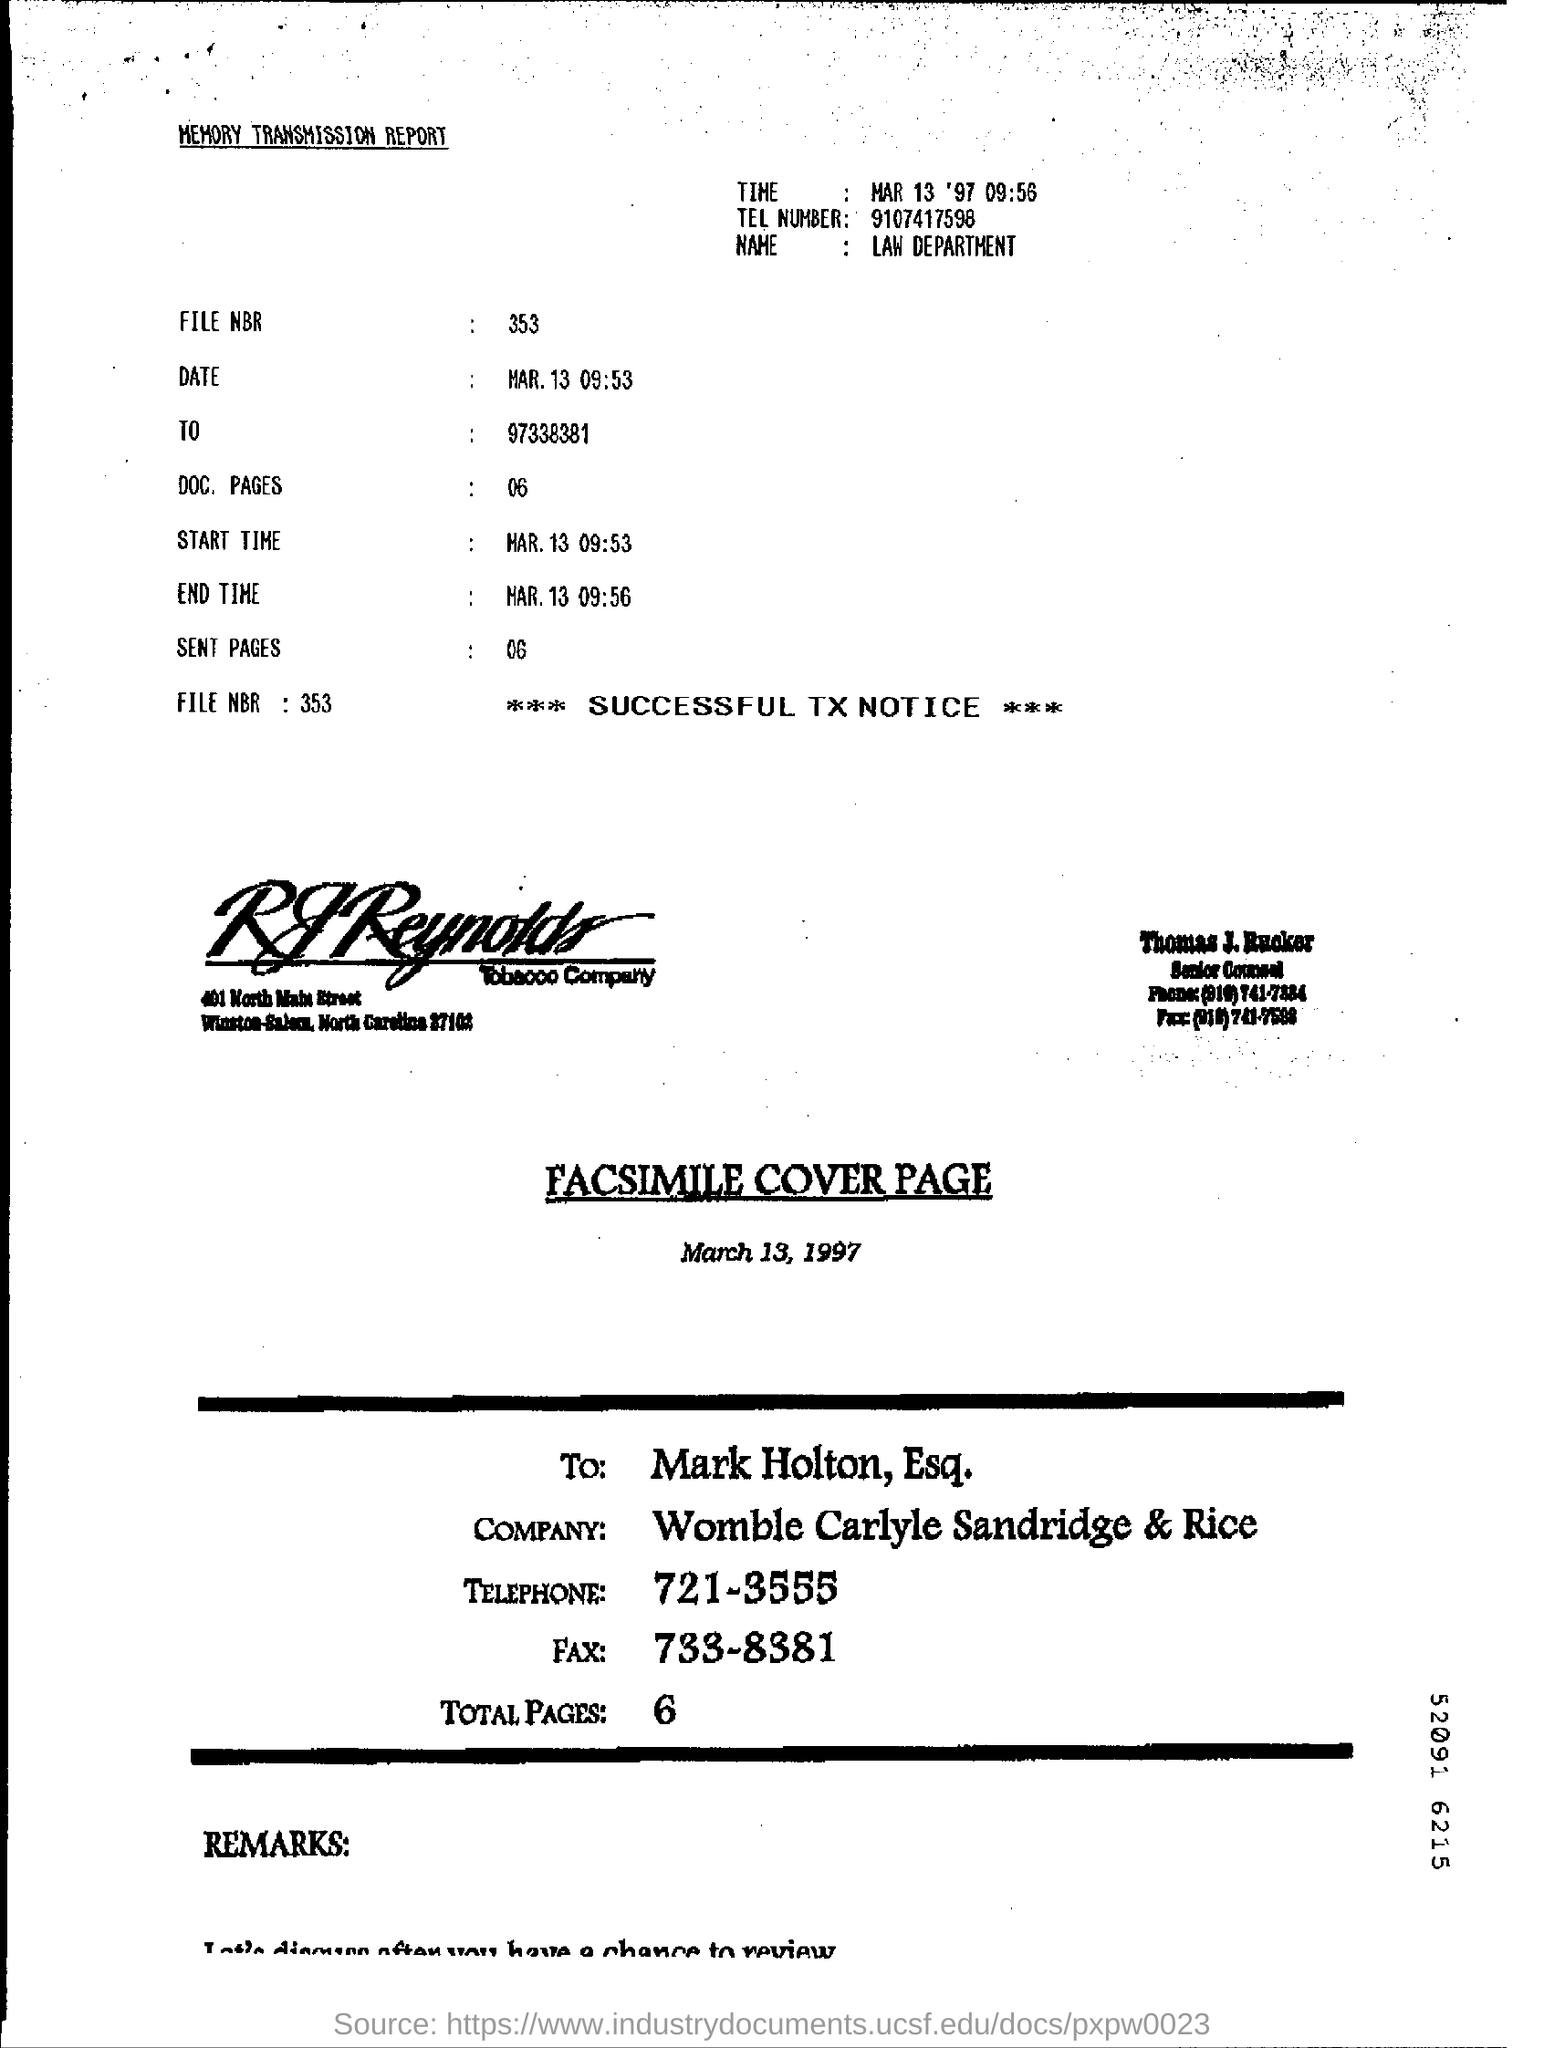Indicate a few pertinent items in this graphic. The number of sent pages is 6. The file number is 353.. I am looking for the telephone number 9107417598. There are 6 pages in the document. 